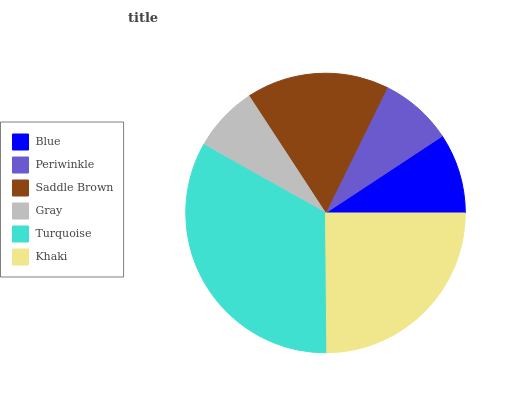Is Gray the minimum?
Answer yes or no. Yes. Is Turquoise the maximum?
Answer yes or no. Yes. Is Periwinkle the minimum?
Answer yes or no. No. Is Periwinkle the maximum?
Answer yes or no. No. Is Blue greater than Periwinkle?
Answer yes or no. Yes. Is Periwinkle less than Blue?
Answer yes or no. Yes. Is Periwinkle greater than Blue?
Answer yes or no. No. Is Blue less than Periwinkle?
Answer yes or no. No. Is Saddle Brown the high median?
Answer yes or no. Yes. Is Blue the low median?
Answer yes or no. Yes. Is Blue the high median?
Answer yes or no. No. Is Khaki the low median?
Answer yes or no. No. 